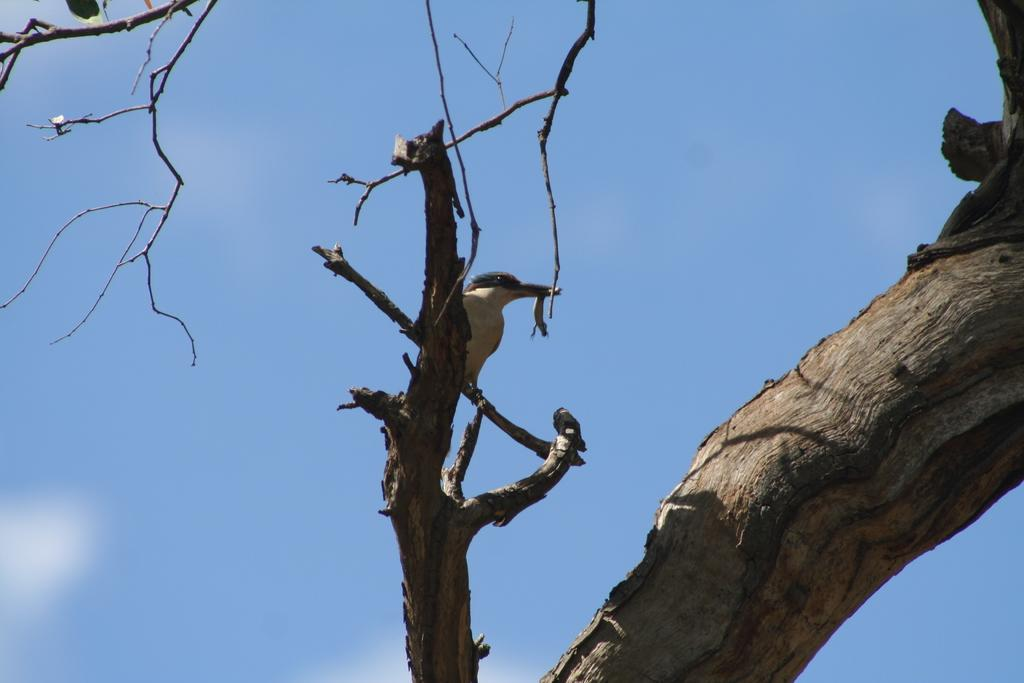What is the main subject in the center of the image? There is a tree in the center of the image. Are there any animals on the tree? Yes, there is a bird on the tree. What can be seen in the background of the image? The sky is visible in the background of the image. What else is present in the background of the image? Clouds are present in the background of the image. What type of bottle can be seen hanging from the tree in the image? There is no bottle present in the image; it only features a tree and a bird. Is there a rabbit visible in the image? No, there is no rabbit present in the image. 